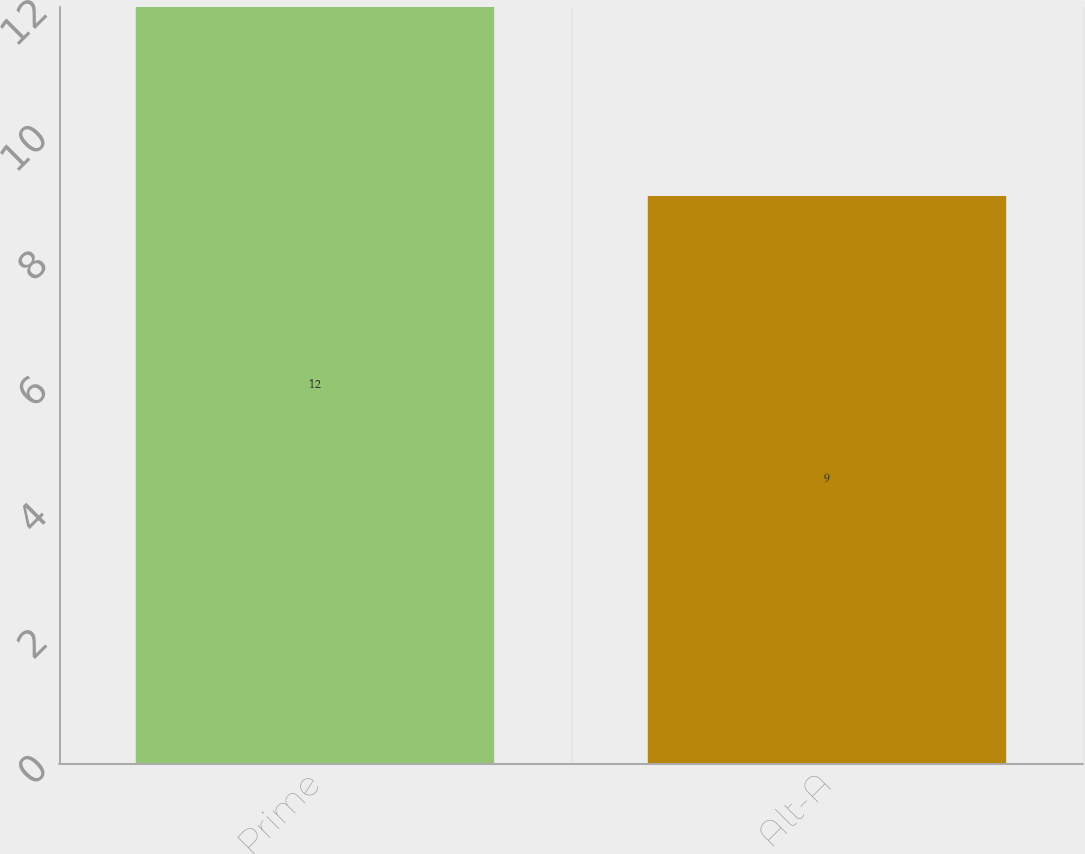Convert chart to OTSL. <chart><loc_0><loc_0><loc_500><loc_500><bar_chart><fcel>Prime<fcel>Alt-A<nl><fcel>12<fcel>9<nl></chart> 